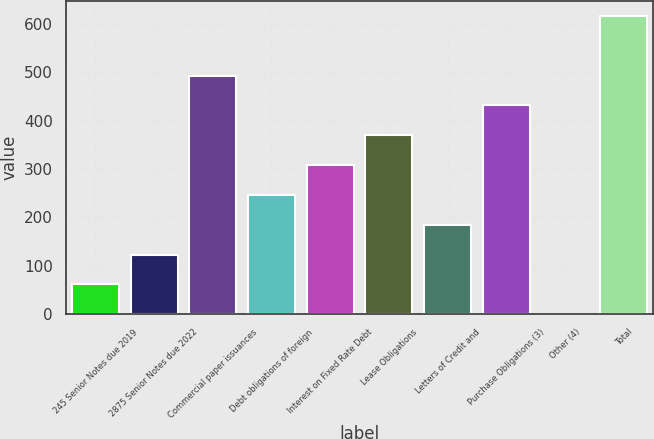Convert chart to OTSL. <chart><loc_0><loc_0><loc_500><loc_500><bar_chart><fcel>245 Senior Notes due 2019<fcel>2875 Senior Notes due 2022<fcel>Commercial paper issuances<fcel>Debt obligations of foreign<fcel>Interest on Fixed Rate Debt<fcel>Lease Obligations<fcel>Letters of Credit and<fcel>Purchase Obligations (3)<fcel>Other (4)<fcel>Total<nl><fcel>62.04<fcel>123.58<fcel>492.82<fcel>246.66<fcel>308.2<fcel>369.74<fcel>185.12<fcel>431.28<fcel>0.5<fcel>615.9<nl></chart> 